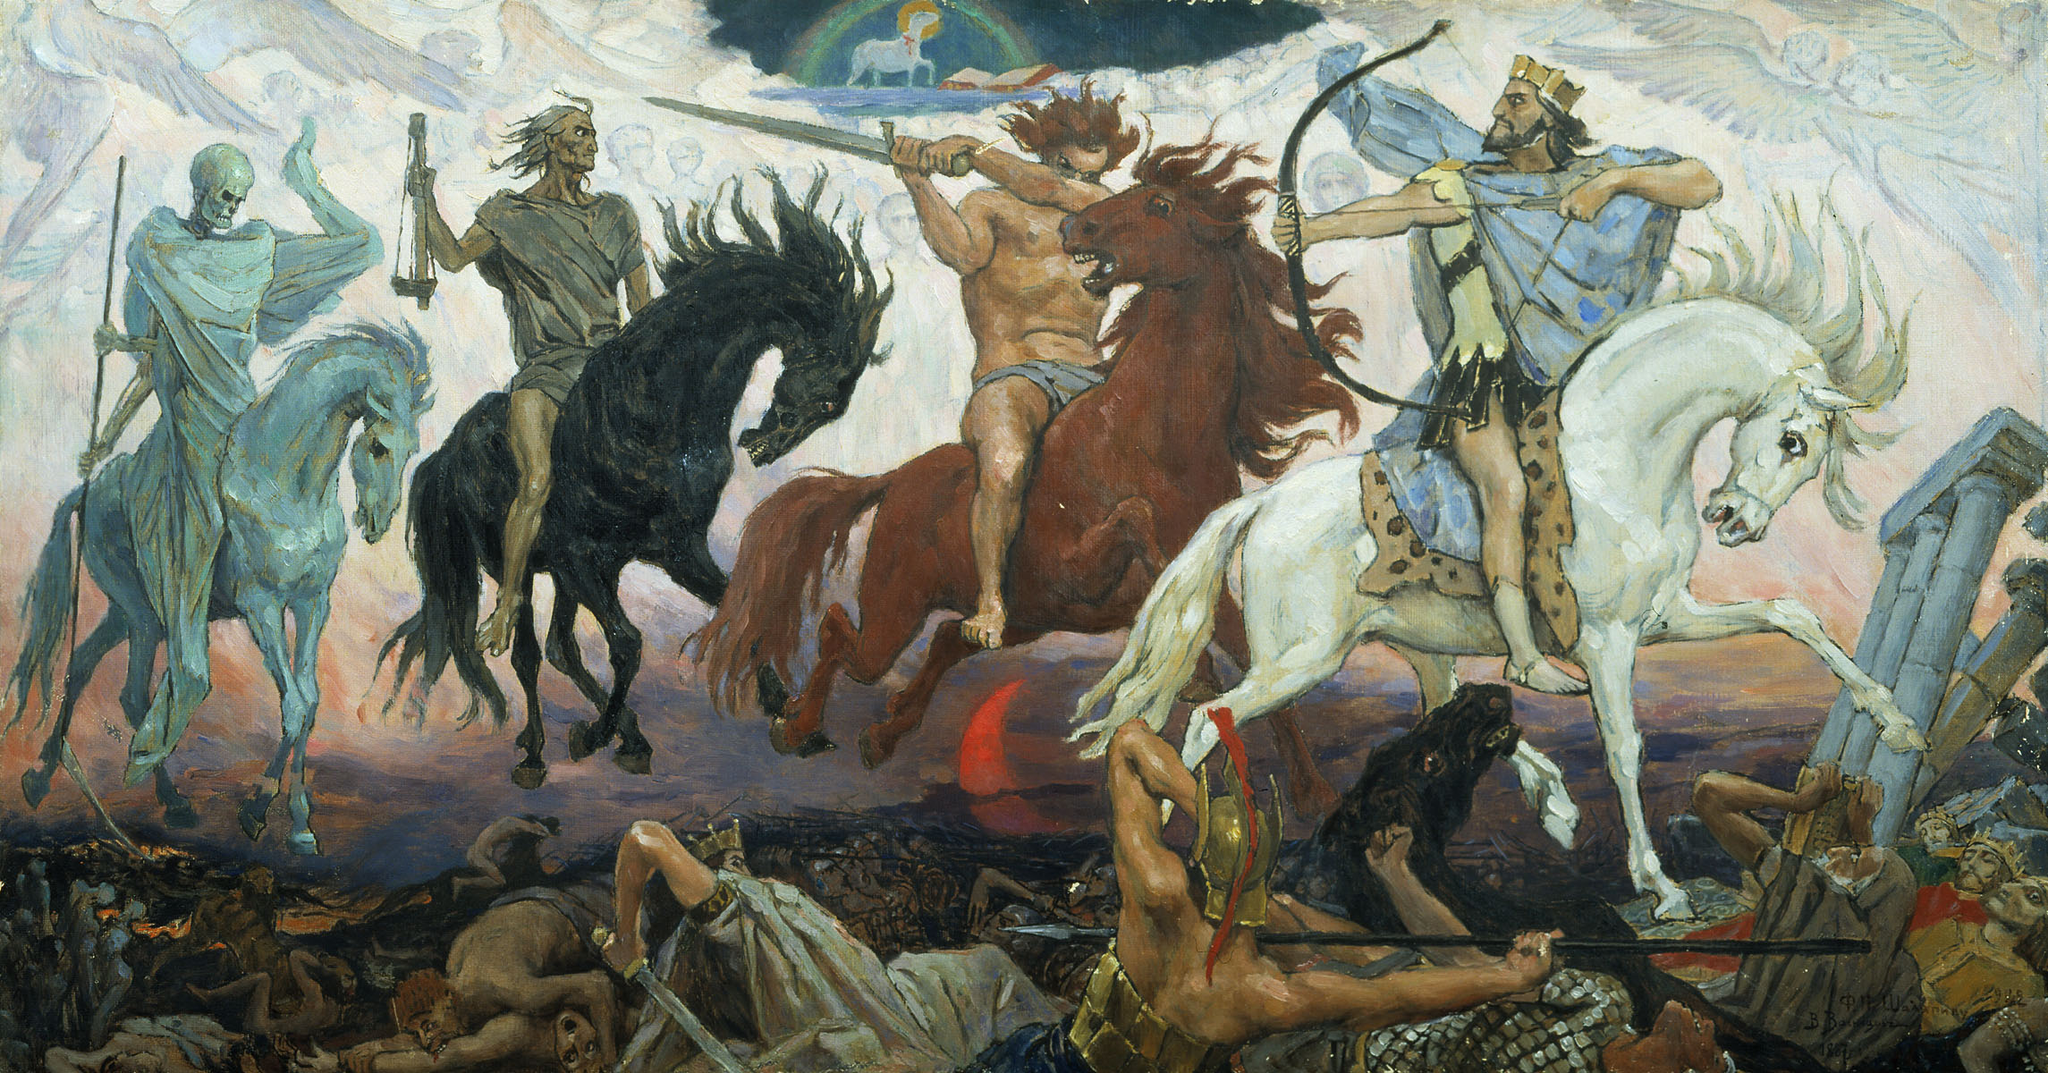What might the fallen figures and chaotic environment say about the historical or allegorical context of this scene? The fallen warriors and tumultuous landscape likely symbolize the destructive nature of war and the tragic human cost it entails. This scene could be portraying an allegorical or historical conquest where victory is overshadowed by loss and ruin, urging the viewer to reflect on the real price of battle. How does the artist utilize light in this composition? The artist expertly uses light to highlight the intensity and motion in the scene. The light seems to emanate from behind the clouds, casting dramatic shadows and illuminating key figures, which accentuates their dynamic movements and expressions, thus contributing to the overall epic narrative of the artwork. 